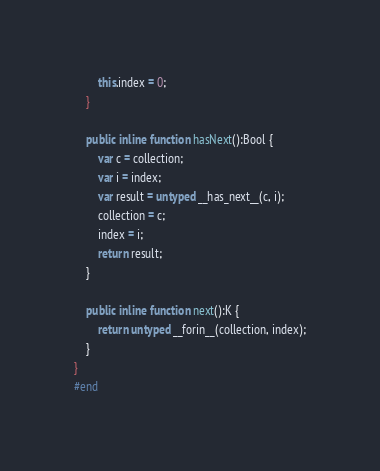<code> <loc_0><loc_0><loc_500><loc_500><_Haxe_>		this.index = 0;
	}

	public inline function hasNext():Bool {
		var c = collection;
		var i = index;
		var result = untyped __has_next__(c, i);
		collection = c;
		index = i;
		return result;
	}

	public inline function next():K {
		return untyped __forin__(collection, index);
	}
}
#end</code> 